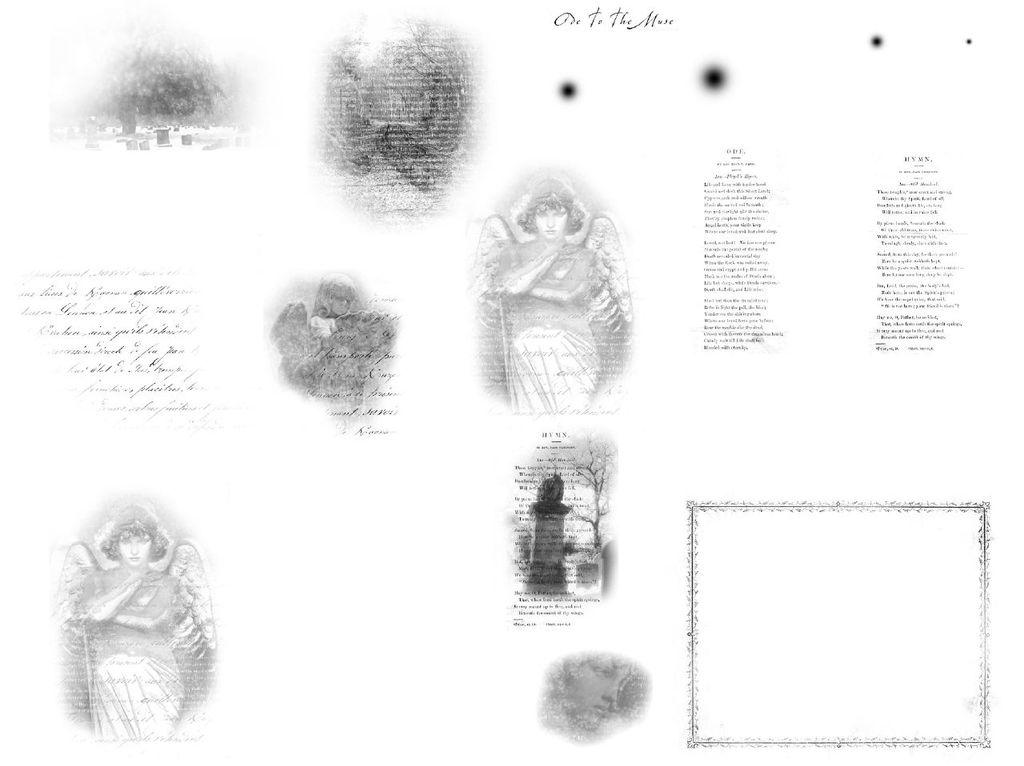What can be seen in the image? There are pictures in the image. What else is present on the image besides the pictures? There is something written on the image. Can you tell me how many buns are in the image? There are no buns present in the image; it only contains pictures and written text. Is there a fireman in the image? There is no fireman present in the image. 